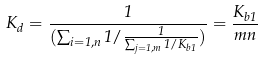<formula> <loc_0><loc_0><loc_500><loc_500>K _ { d } = \frac { 1 } { ( \sum _ { i = 1 , n } 1 / \frac { 1 } { \sum _ { j = 1 , m } 1 / K _ { b 1 } } ) } = \frac { K _ { b 1 } } { m n }</formula> 